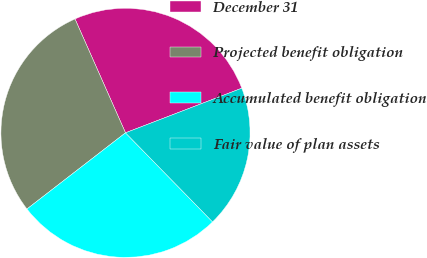Convert chart. <chart><loc_0><loc_0><loc_500><loc_500><pie_chart><fcel>December 31<fcel>Projected benefit obligation<fcel>Accumulated benefit obligation<fcel>Fair value of plan assets<nl><fcel>25.81%<fcel>28.83%<fcel>26.84%<fcel>18.51%<nl></chart> 